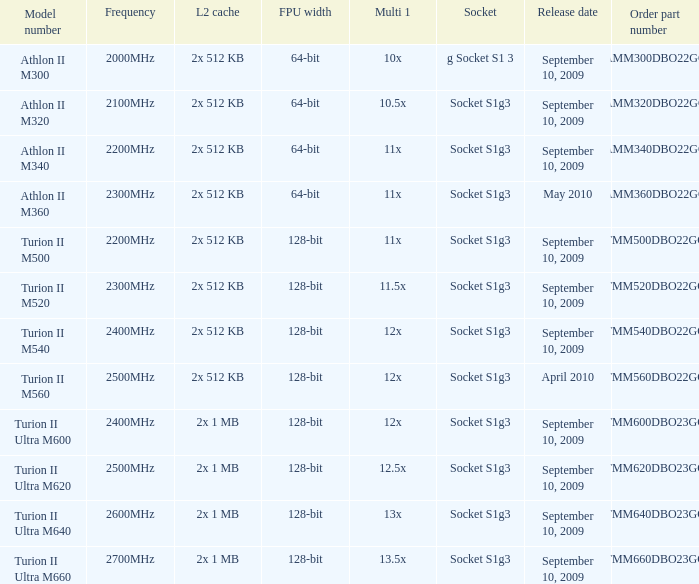What is the order part number with a 12.5x multi 1? TMM620DBO23GQ. 